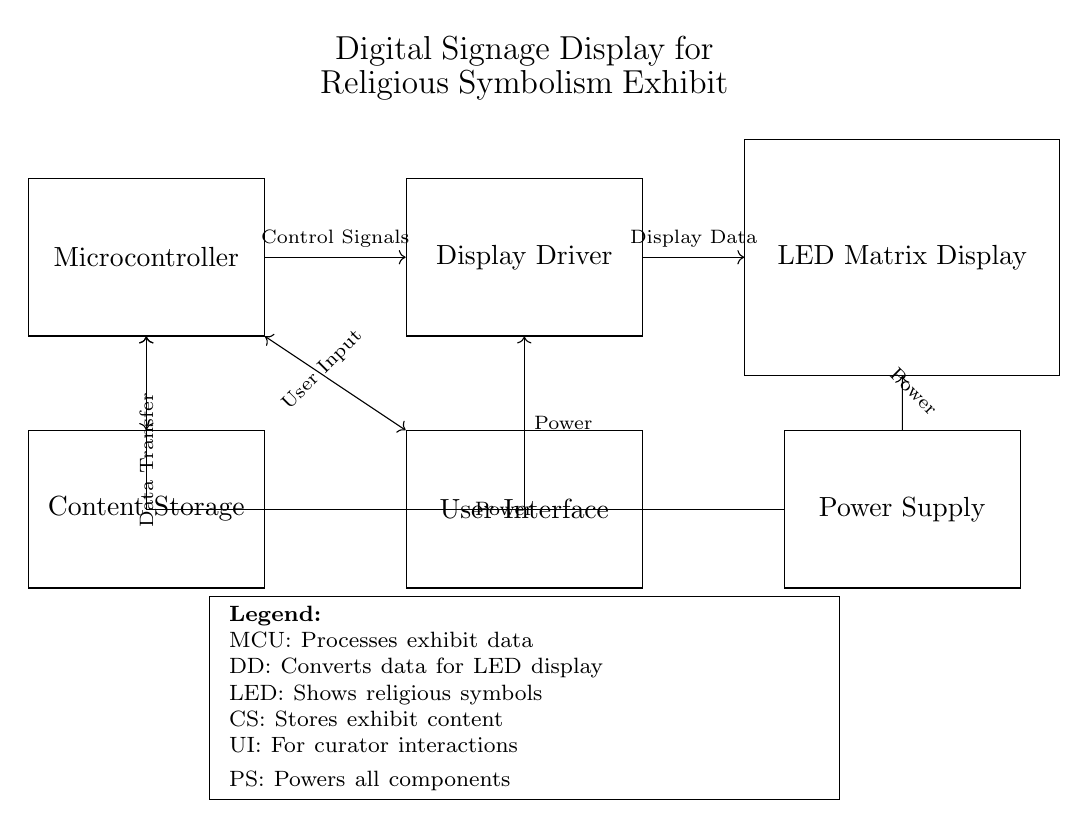What is the main control unit in this circuit? The main control unit is the Microcontroller, which processes the data for the exhibit. This is indicated by the rectangle labeled "Microcontroller" in the diagram.
Answer: Microcontroller What does the Display Driver do? The Display Driver converts the data received from the Microcontroller for display on the LED Matrix. This function is noted in the diagram by the rectangle labeled "Display Driver."
Answer: Converts data What is the purpose of the Content Storage? The Content Storage stores the exhibit content that the Microcontroller will process and manage. The function is shown in the diagram with the label "Content Storage."
Answer: Stores content What type of display is used in this circuit? The circuit uses an LED Matrix Display, indicated by the rectangle labeled "LED Matrix Display." It serves to show religious symbols as part of the exhibit.
Answer: LED Matrix Display How does the Power Supply connect to components? The Power Supply connects through directed arrows to the Microcontroller, Display Driver, and LED Matrix, delivering power to all components. The connections can be traced from the labeled rectangle "Power Supply" to these units.
Answer: Through directed connections What is the nature of the connection between the Microcontroller and the User Interface? The connection between the Microcontroller and the User Interface is bi-directional for user input, signified by the two-headed arrow. This means that data can flow in both directions, allowing interaction from the user.
Answer: Bi-directional What function does the User Interface serve in this circuit? The User Interface allows the curator to interact with the system, sending user input to the Microcontroller. This function is represented in the diagram with the label "User Interface."
Answer: Interaction 